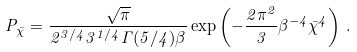Convert formula to latex. <formula><loc_0><loc_0><loc_500><loc_500>P _ { \bar { \chi } } = \frac { \sqrt { \pi } } { 2 ^ { 3 / 4 } 3 ^ { 1 / 4 } \Gamma ( 5 / 4 ) \beta } \exp \left ( - \frac { 2 \pi ^ { 2 } } { 3 } \beta ^ { - 4 } \bar { \chi } ^ { 4 } \right ) \, .</formula> 